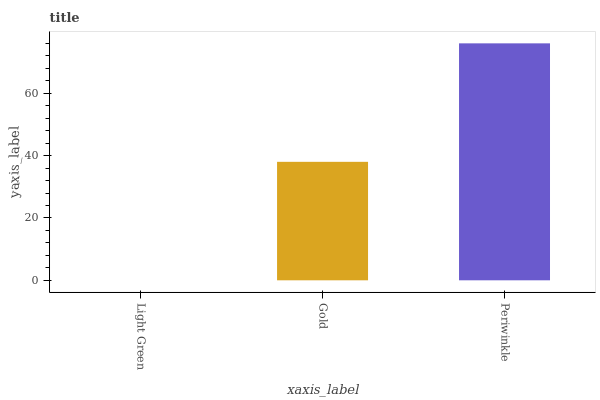Is Light Green the minimum?
Answer yes or no. Yes. Is Periwinkle the maximum?
Answer yes or no. Yes. Is Gold the minimum?
Answer yes or no. No. Is Gold the maximum?
Answer yes or no. No. Is Gold greater than Light Green?
Answer yes or no. Yes. Is Light Green less than Gold?
Answer yes or no. Yes. Is Light Green greater than Gold?
Answer yes or no. No. Is Gold less than Light Green?
Answer yes or no. No. Is Gold the high median?
Answer yes or no. Yes. Is Gold the low median?
Answer yes or no. Yes. Is Periwinkle the high median?
Answer yes or no. No. Is Light Green the low median?
Answer yes or no. No. 